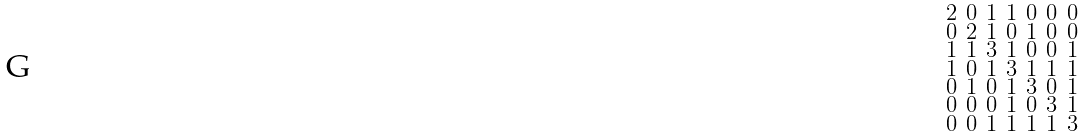<formula> <loc_0><loc_0><loc_500><loc_500>\begin{smallmatrix} 2 & 0 & 1 & 1 & 0 & 0 & 0 \\ 0 & 2 & 1 & 0 & 1 & 0 & 0 \\ 1 & 1 & 3 & 1 & 0 & 0 & 1 \\ 1 & 0 & 1 & 3 & 1 & 1 & 1 \\ 0 & 1 & 0 & 1 & 3 & 0 & 1 \\ 0 & 0 & 0 & 1 & 0 & 3 & 1 \\ 0 & 0 & 1 & 1 & 1 & 1 & 3 \end{smallmatrix}</formula> 